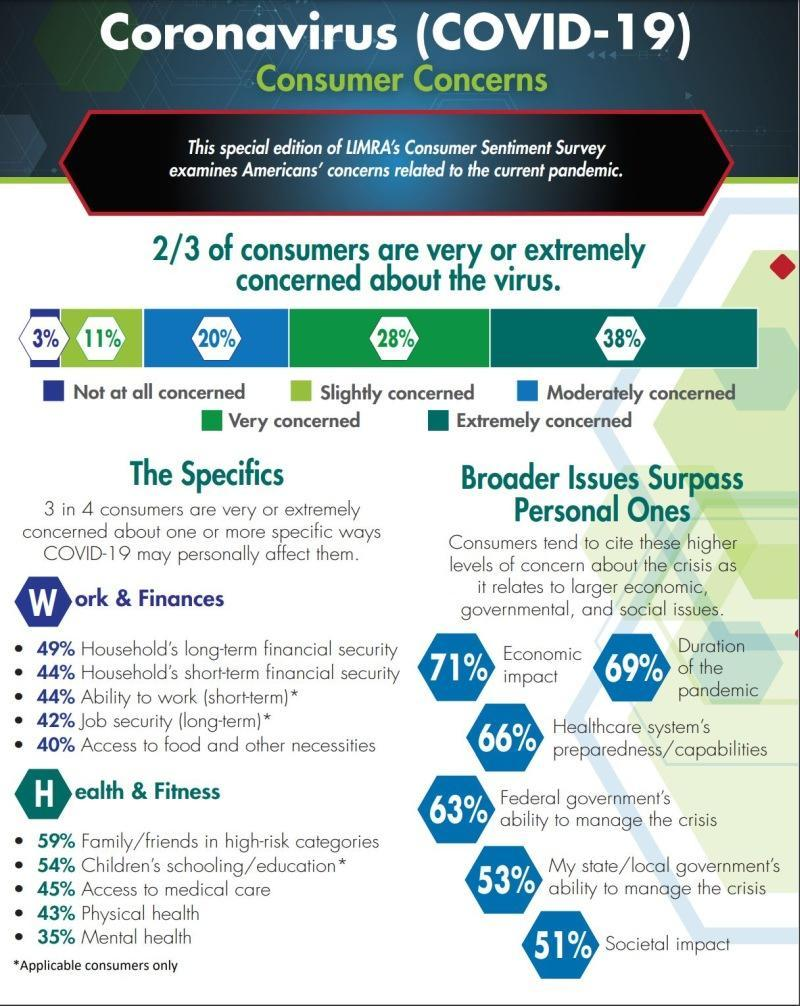Which issue is the most concerning under broader issues?
Answer the question with a short phrase. Economic impact What percent of consumers are very concerned about the virus? 28% 